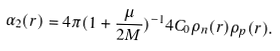<formula> <loc_0><loc_0><loc_500><loc_500>\alpha _ { 2 } ( r ) = 4 \pi ( 1 + \frac { \mu } { 2 M } ) ^ { - 1 } 4 C _ { 0 } \rho _ { n } ( r ) \rho _ { p } ( r ) .</formula> 